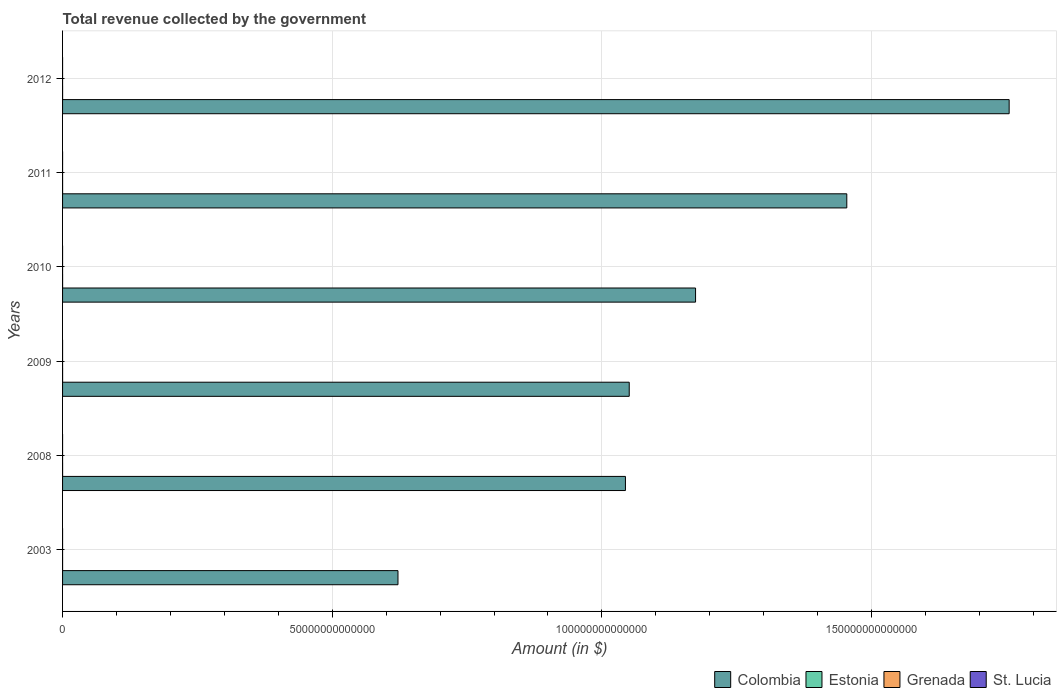How many bars are there on the 5th tick from the bottom?
Make the answer very short. 4. What is the label of the 2nd group of bars from the top?
Make the answer very short. 2011. What is the total revenue collected by the government in Estonia in 2012?
Your answer should be compact. 5.80e+09. Across all years, what is the maximum total revenue collected by the government in St. Lucia?
Provide a short and direct response. 8.17e+08. Across all years, what is the minimum total revenue collected by the government in St. Lucia?
Provide a succinct answer. 4.67e+08. In which year was the total revenue collected by the government in Estonia maximum?
Provide a succinct answer. 2012. What is the total total revenue collected by the government in Colombia in the graph?
Offer a very short reply. 7.10e+14. What is the difference between the total revenue collected by the government in Estonia in 2010 and that in 2011?
Give a very brief answer. -3.56e+08. What is the difference between the total revenue collected by the government in Grenada in 2011 and the total revenue collected by the government in Colombia in 2012?
Make the answer very short. -1.76e+14. What is the average total revenue collected by the government in Estonia per year?
Make the answer very short. 4.79e+09. In the year 2012, what is the difference between the total revenue collected by the government in Colombia and total revenue collected by the government in Estonia?
Provide a succinct answer. 1.76e+14. In how many years, is the total revenue collected by the government in Colombia greater than 30000000000000 $?
Provide a succinct answer. 6. What is the ratio of the total revenue collected by the government in Grenada in 2010 to that in 2012?
Offer a terse response. 0.98. Is the difference between the total revenue collected by the government in Colombia in 2009 and 2012 greater than the difference between the total revenue collected by the government in Estonia in 2009 and 2012?
Give a very brief answer. No. What is the difference between the highest and the second highest total revenue collected by the government in Colombia?
Provide a short and direct response. 3.01e+13. What is the difference between the highest and the lowest total revenue collected by the government in Colombia?
Make the answer very short. 1.13e+14. Is the sum of the total revenue collected by the government in Grenada in 2010 and 2011 greater than the maximum total revenue collected by the government in St. Lucia across all years?
Ensure brevity in your answer.  Yes. What does the 1st bar from the top in 2003 represents?
Provide a short and direct response. St. Lucia. What does the 3rd bar from the bottom in 2012 represents?
Give a very brief answer. Grenada. Are all the bars in the graph horizontal?
Provide a succinct answer. Yes. What is the difference between two consecutive major ticks on the X-axis?
Make the answer very short. 5.00e+13. Does the graph contain any zero values?
Provide a short and direct response. No. Does the graph contain grids?
Make the answer very short. Yes. Where does the legend appear in the graph?
Your answer should be compact. Bottom right. How many legend labels are there?
Provide a short and direct response. 4. How are the legend labels stacked?
Make the answer very short. Horizontal. What is the title of the graph?
Give a very brief answer. Total revenue collected by the government. What is the label or title of the X-axis?
Make the answer very short. Amount (in $). What is the Amount (in $) of Colombia in 2003?
Give a very brief answer. 6.22e+13. What is the Amount (in $) in Estonia in 2003?
Keep it short and to the point. 2.60e+09. What is the Amount (in $) in Grenada in 2003?
Offer a very short reply. 3.24e+08. What is the Amount (in $) in St. Lucia in 2003?
Offer a very short reply. 4.67e+08. What is the Amount (in $) of Colombia in 2008?
Offer a very short reply. 1.04e+14. What is the Amount (in $) in Estonia in 2008?
Ensure brevity in your answer.  4.98e+09. What is the Amount (in $) of Grenada in 2008?
Your answer should be very brief. 4.65e+08. What is the Amount (in $) in St. Lucia in 2008?
Offer a very short reply. 7.81e+08. What is the Amount (in $) of Colombia in 2009?
Keep it short and to the point. 1.05e+14. What is the Amount (in $) in Estonia in 2009?
Your answer should be very brief. 5.06e+09. What is the Amount (in $) in Grenada in 2009?
Provide a succinct answer. 4.02e+08. What is the Amount (in $) in St. Lucia in 2009?
Your answer should be compact. 7.71e+08. What is the Amount (in $) of Colombia in 2010?
Ensure brevity in your answer.  1.17e+14. What is the Amount (in $) in Estonia in 2010?
Provide a succinct answer. 4.96e+09. What is the Amount (in $) in Grenada in 2010?
Make the answer very short. 4.15e+08. What is the Amount (in $) of St. Lucia in 2010?
Offer a very short reply. 7.76e+08. What is the Amount (in $) of Colombia in 2011?
Offer a terse response. 1.45e+14. What is the Amount (in $) in Estonia in 2011?
Offer a very short reply. 5.31e+09. What is the Amount (in $) of Grenada in 2011?
Your answer should be very brief. 4.26e+08. What is the Amount (in $) in St. Lucia in 2011?
Keep it short and to the point. 8.17e+08. What is the Amount (in $) of Colombia in 2012?
Offer a very short reply. 1.76e+14. What is the Amount (in $) in Estonia in 2012?
Give a very brief answer. 5.80e+09. What is the Amount (in $) in Grenada in 2012?
Make the answer very short. 4.25e+08. What is the Amount (in $) in St. Lucia in 2012?
Provide a succinct answer. 8.10e+08. Across all years, what is the maximum Amount (in $) of Colombia?
Offer a terse response. 1.76e+14. Across all years, what is the maximum Amount (in $) of Estonia?
Offer a terse response. 5.80e+09. Across all years, what is the maximum Amount (in $) of Grenada?
Your answer should be compact. 4.65e+08. Across all years, what is the maximum Amount (in $) of St. Lucia?
Make the answer very short. 8.17e+08. Across all years, what is the minimum Amount (in $) in Colombia?
Give a very brief answer. 6.22e+13. Across all years, what is the minimum Amount (in $) in Estonia?
Offer a terse response. 2.60e+09. Across all years, what is the minimum Amount (in $) in Grenada?
Keep it short and to the point. 3.24e+08. Across all years, what is the minimum Amount (in $) in St. Lucia?
Provide a succinct answer. 4.67e+08. What is the total Amount (in $) of Colombia in the graph?
Your response must be concise. 7.10e+14. What is the total Amount (in $) in Estonia in the graph?
Keep it short and to the point. 2.87e+1. What is the total Amount (in $) of Grenada in the graph?
Your answer should be compact. 2.46e+09. What is the total Amount (in $) of St. Lucia in the graph?
Your answer should be very brief. 4.42e+09. What is the difference between the Amount (in $) of Colombia in 2003 and that in 2008?
Offer a terse response. -4.22e+13. What is the difference between the Amount (in $) of Estonia in 2003 and that in 2008?
Your answer should be compact. -2.39e+09. What is the difference between the Amount (in $) of Grenada in 2003 and that in 2008?
Provide a succinct answer. -1.41e+08. What is the difference between the Amount (in $) in St. Lucia in 2003 and that in 2008?
Your answer should be compact. -3.15e+08. What is the difference between the Amount (in $) in Colombia in 2003 and that in 2009?
Your answer should be compact. -4.29e+13. What is the difference between the Amount (in $) of Estonia in 2003 and that in 2009?
Your response must be concise. -2.47e+09. What is the difference between the Amount (in $) of Grenada in 2003 and that in 2009?
Your answer should be compact. -7.82e+07. What is the difference between the Amount (in $) in St. Lucia in 2003 and that in 2009?
Provide a short and direct response. -3.04e+08. What is the difference between the Amount (in $) of Colombia in 2003 and that in 2010?
Your answer should be very brief. -5.52e+13. What is the difference between the Amount (in $) in Estonia in 2003 and that in 2010?
Provide a succinct answer. -2.36e+09. What is the difference between the Amount (in $) in Grenada in 2003 and that in 2010?
Offer a very short reply. -9.14e+07. What is the difference between the Amount (in $) of St. Lucia in 2003 and that in 2010?
Your response must be concise. -3.10e+08. What is the difference between the Amount (in $) of Colombia in 2003 and that in 2011?
Provide a succinct answer. -8.32e+13. What is the difference between the Amount (in $) of Estonia in 2003 and that in 2011?
Make the answer very short. -2.72e+09. What is the difference between the Amount (in $) of Grenada in 2003 and that in 2011?
Offer a very short reply. -1.02e+08. What is the difference between the Amount (in $) in St. Lucia in 2003 and that in 2011?
Make the answer very short. -3.50e+08. What is the difference between the Amount (in $) of Colombia in 2003 and that in 2012?
Give a very brief answer. -1.13e+14. What is the difference between the Amount (in $) in Estonia in 2003 and that in 2012?
Offer a very short reply. -3.20e+09. What is the difference between the Amount (in $) of Grenada in 2003 and that in 2012?
Offer a terse response. -1.02e+08. What is the difference between the Amount (in $) in St. Lucia in 2003 and that in 2012?
Your response must be concise. -3.44e+08. What is the difference between the Amount (in $) of Colombia in 2008 and that in 2009?
Offer a very short reply. -7.04e+11. What is the difference between the Amount (in $) in Estonia in 2008 and that in 2009?
Offer a very short reply. -7.78e+07. What is the difference between the Amount (in $) in Grenada in 2008 and that in 2009?
Offer a terse response. 6.28e+07. What is the difference between the Amount (in $) in St. Lucia in 2008 and that in 2009?
Provide a succinct answer. 1.03e+07. What is the difference between the Amount (in $) of Colombia in 2008 and that in 2010?
Ensure brevity in your answer.  -1.30e+13. What is the difference between the Amount (in $) in Estonia in 2008 and that in 2010?
Provide a short and direct response. 2.82e+07. What is the difference between the Amount (in $) of Grenada in 2008 and that in 2010?
Your response must be concise. 4.96e+07. What is the difference between the Amount (in $) in St. Lucia in 2008 and that in 2010?
Ensure brevity in your answer.  4.90e+06. What is the difference between the Amount (in $) of Colombia in 2008 and that in 2011?
Keep it short and to the point. -4.10e+13. What is the difference between the Amount (in $) in Estonia in 2008 and that in 2011?
Give a very brief answer. -3.28e+08. What is the difference between the Amount (in $) in Grenada in 2008 and that in 2011?
Provide a short and direct response. 3.89e+07. What is the difference between the Amount (in $) of St. Lucia in 2008 and that in 2011?
Your answer should be very brief. -3.54e+07. What is the difference between the Amount (in $) of Colombia in 2008 and that in 2012?
Your answer should be very brief. -7.12e+13. What is the difference between the Amount (in $) of Estonia in 2008 and that in 2012?
Your response must be concise. -8.14e+08. What is the difference between the Amount (in $) in Grenada in 2008 and that in 2012?
Keep it short and to the point. 3.93e+07. What is the difference between the Amount (in $) of St. Lucia in 2008 and that in 2012?
Provide a succinct answer. -2.92e+07. What is the difference between the Amount (in $) in Colombia in 2009 and that in 2010?
Ensure brevity in your answer.  -1.23e+13. What is the difference between the Amount (in $) of Estonia in 2009 and that in 2010?
Your answer should be compact. 1.06e+08. What is the difference between the Amount (in $) in Grenada in 2009 and that in 2010?
Provide a succinct answer. -1.32e+07. What is the difference between the Amount (in $) in St. Lucia in 2009 and that in 2010?
Your answer should be very brief. -5.40e+06. What is the difference between the Amount (in $) of Colombia in 2009 and that in 2011?
Make the answer very short. -4.03e+13. What is the difference between the Amount (in $) of Estonia in 2009 and that in 2011?
Ensure brevity in your answer.  -2.50e+08. What is the difference between the Amount (in $) of Grenada in 2009 and that in 2011?
Offer a very short reply. -2.39e+07. What is the difference between the Amount (in $) in St. Lucia in 2009 and that in 2011?
Give a very brief answer. -4.57e+07. What is the difference between the Amount (in $) in Colombia in 2009 and that in 2012?
Ensure brevity in your answer.  -7.05e+13. What is the difference between the Amount (in $) in Estonia in 2009 and that in 2012?
Keep it short and to the point. -7.36e+08. What is the difference between the Amount (in $) of Grenada in 2009 and that in 2012?
Your answer should be compact. -2.35e+07. What is the difference between the Amount (in $) of St. Lucia in 2009 and that in 2012?
Keep it short and to the point. -3.95e+07. What is the difference between the Amount (in $) of Colombia in 2010 and that in 2011?
Provide a short and direct response. -2.80e+13. What is the difference between the Amount (in $) in Estonia in 2010 and that in 2011?
Ensure brevity in your answer.  -3.56e+08. What is the difference between the Amount (in $) of Grenada in 2010 and that in 2011?
Your answer should be compact. -1.07e+07. What is the difference between the Amount (in $) of St. Lucia in 2010 and that in 2011?
Offer a very short reply. -4.03e+07. What is the difference between the Amount (in $) of Colombia in 2010 and that in 2012?
Your answer should be compact. -5.81e+13. What is the difference between the Amount (in $) of Estonia in 2010 and that in 2012?
Your answer should be very brief. -8.42e+08. What is the difference between the Amount (in $) of Grenada in 2010 and that in 2012?
Provide a succinct answer. -1.03e+07. What is the difference between the Amount (in $) of St. Lucia in 2010 and that in 2012?
Your answer should be very brief. -3.41e+07. What is the difference between the Amount (in $) in Colombia in 2011 and that in 2012?
Ensure brevity in your answer.  -3.01e+13. What is the difference between the Amount (in $) in Estonia in 2011 and that in 2012?
Your response must be concise. -4.86e+08. What is the difference between the Amount (in $) in St. Lucia in 2011 and that in 2012?
Offer a terse response. 6.20e+06. What is the difference between the Amount (in $) of Colombia in 2003 and the Amount (in $) of Estonia in 2008?
Give a very brief answer. 6.22e+13. What is the difference between the Amount (in $) of Colombia in 2003 and the Amount (in $) of Grenada in 2008?
Make the answer very short. 6.22e+13. What is the difference between the Amount (in $) of Colombia in 2003 and the Amount (in $) of St. Lucia in 2008?
Your response must be concise. 6.22e+13. What is the difference between the Amount (in $) in Estonia in 2003 and the Amount (in $) in Grenada in 2008?
Give a very brief answer. 2.13e+09. What is the difference between the Amount (in $) in Estonia in 2003 and the Amount (in $) in St. Lucia in 2008?
Give a very brief answer. 1.82e+09. What is the difference between the Amount (in $) in Grenada in 2003 and the Amount (in $) in St. Lucia in 2008?
Your answer should be very brief. -4.58e+08. What is the difference between the Amount (in $) of Colombia in 2003 and the Amount (in $) of Estonia in 2009?
Your answer should be very brief. 6.22e+13. What is the difference between the Amount (in $) of Colombia in 2003 and the Amount (in $) of Grenada in 2009?
Offer a very short reply. 6.22e+13. What is the difference between the Amount (in $) of Colombia in 2003 and the Amount (in $) of St. Lucia in 2009?
Provide a short and direct response. 6.22e+13. What is the difference between the Amount (in $) in Estonia in 2003 and the Amount (in $) in Grenada in 2009?
Your response must be concise. 2.20e+09. What is the difference between the Amount (in $) in Estonia in 2003 and the Amount (in $) in St. Lucia in 2009?
Make the answer very short. 1.83e+09. What is the difference between the Amount (in $) in Grenada in 2003 and the Amount (in $) in St. Lucia in 2009?
Make the answer very short. -4.47e+08. What is the difference between the Amount (in $) of Colombia in 2003 and the Amount (in $) of Estonia in 2010?
Provide a succinct answer. 6.22e+13. What is the difference between the Amount (in $) in Colombia in 2003 and the Amount (in $) in Grenada in 2010?
Your answer should be very brief. 6.22e+13. What is the difference between the Amount (in $) of Colombia in 2003 and the Amount (in $) of St. Lucia in 2010?
Make the answer very short. 6.22e+13. What is the difference between the Amount (in $) in Estonia in 2003 and the Amount (in $) in Grenada in 2010?
Provide a succinct answer. 2.18e+09. What is the difference between the Amount (in $) in Estonia in 2003 and the Amount (in $) in St. Lucia in 2010?
Your response must be concise. 1.82e+09. What is the difference between the Amount (in $) in Grenada in 2003 and the Amount (in $) in St. Lucia in 2010?
Offer a terse response. -4.53e+08. What is the difference between the Amount (in $) in Colombia in 2003 and the Amount (in $) in Estonia in 2011?
Make the answer very short. 6.22e+13. What is the difference between the Amount (in $) of Colombia in 2003 and the Amount (in $) of Grenada in 2011?
Provide a short and direct response. 6.22e+13. What is the difference between the Amount (in $) in Colombia in 2003 and the Amount (in $) in St. Lucia in 2011?
Provide a succinct answer. 6.22e+13. What is the difference between the Amount (in $) in Estonia in 2003 and the Amount (in $) in Grenada in 2011?
Ensure brevity in your answer.  2.17e+09. What is the difference between the Amount (in $) of Estonia in 2003 and the Amount (in $) of St. Lucia in 2011?
Make the answer very short. 1.78e+09. What is the difference between the Amount (in $) of Grenada in 2003 and the Amount (in $) of St. Lucia in 2011?
Your answer should be very brief. -4.93e+08. What is the difference between the Amount (in $) in Colombia in 2003 and the Amount (in $) in Estonia in 2012?
Your answer should be compact. 6.22e+13. What is the difference between the Amount (in $) of Colombia in 2003 and the Amount (in $) of Grenada in 2012?
Make the answer very short. 6.22e+13. What is the difference between the Amount (in $) in Colombia in 2003 and the Amount (in $) in St. Lucia in 2012?
Make the answer very short. 6.22e+13. What is the difference between the Amount (in $) in Estonia in 2003 and the Amount (in $) in Grenada in 2012?
Provide a succinct answer. 2.17e+09. What is the difference between the Amount (in $) in Estonia in 2003 and the Amount (in $) in St. Lucia in 2012?
Your answer should be very brief. 1.79e+09. What is the difference between the Amount (in $) in Grenada in 2003 and the Amount (in $) in St. Lucia in 2012?
Make the answer very short. -4.87e+08. What is the difference between the Amount (in $) of Colombia in 2008 and the Amount (in $) of Estonia in 2009?
Provide a succinct answer. 1.04e+14. What is the difference between the Amount (in $) in Colombia in 2008 and the Amount (in $) in Grenada in 2009?
Ensure brevity in your answer.  1.04e+14. What is the difference between the Amount (in $) in Colombia in 2008 and the Amount (in $) in St. Lucia in 2009?
Your answer should be compact. 1.04e+14. What is the difference between the Amount (in $) in Estonia in 2008 and the Amount (in $) in Grenada in 2009?
Keep it short and to the point. 4.58e+09. What is the difference between the Amount (in $) of Estonia in 2008 and the Amount (in $) of St. Lucia in 2009?
Offer a very short reply. 4.21e+09. What is the difference between the Amount (in $) of Grenada in 2008 and the Amount (in $) of St. Lucia in 2009?
Offer a very short reply. -3.06e+08. What is the difference between the Amount (in $) of Colombia in 2008 and the Amount (in $) of Estonia in 2010?
Your answer should be compact. 1.04e+14. What is the difference between the Amount (in $) of Colombia in 2008 and the Amount (in $) of Grenada in 2010?
Keep it short and to the point. 1.04e+14. What is the difference between the Amount (in $) in Colombia in 2008 and the Amount (in $) in St. Lucia in 2010?
Your response must be concise. 1.04e+14. What is the difference between the Amount (in $) in Estonia in 2008 and the Amount (in $) in Grenada in 2010?
Provide a succinct answer. 4.57e+09. What is the difference between the Amount (in $) in Estonia in 2008 and the Amount (in $) in St. Lucia in 2010?
Ensure brevity in your answer.  4.21e+09. What is the difference between the Amount (in $) in Grenada in 2008 and the Amount (in $) in St. Lucia in 2010?
Your answer should be compact. -3.12e+08. What is the difference between the Amount (in $) in Colombia in 2008 and the Amount (in $) in Estonia in 2011?
Keep it short and to the point. 1.04e+14. What is the difference between the Amount (in $) in Colombia in 2008 and the Amount (in $) in Grenada in 2011?
Offer a very short reply. 1.04e+14. What is the difference between the Amount (in $) of Colombia in 2008 and the Amount (in $) of St. Lucia in 2011?
Ensure brevity in your answer.  1.04e+14. What is the difference between the Amount (in $) in Estonia in 2008 and the Amount (in $) in Grenada in 2011?
Offer a terse response. 4.56e+09. What is the difference between the Amount (in $) of Estonia in 2008 and the Amount (in $) of St. Lucia in 2011?
Your answer should be compact. 4.17e+09. What is the difference between the Amount (in $) in Grenada in 2008 and the Amount (in $) in St. Lucia in 2011?
Your answer should be very brief. -3.52e+08. What is the difference between the Amount (in $) in Colombia in 2008 and the Amount (in $) in Estonia in 2012?
Your response must be concise. 1.04e+14. What is the difference between the Amount (in $) of Colombia in 2008 and the Amount (in $) of Grenada in 2012?
Your answer should be very brief. 1.04e+14. What is the difference between the Amount (in $) of Colombia in 2008 and the Amount (in $) of St. Lucia in 2012?
Offer a terse response. 1.04e+14. What is the difference between the Amount (in $) in Estonia in 2008 and the Amount (in $) in Grenada in 2012?
Provide a short and direct response. 4.56e+09. What is the difference between the Amount (in $) in Estonia in 2008 and the Amount (in $) in St. Lucia in 2012?
Make the answer very short. 4.17e+09. What is the difference between the Amount (in $) in Grenada in 2008 and the Amount (in $) in St. Lucia in 2012?
Your answer should be very brief. -3.46e+08. What is the difference between the Amount (in $) of Colombia in 2009 and the Amount (in $) of Estonia in 2010?
Make the answer very short. 1.05e+14. What is the difference between the Amount (in $) of Colombia in 2009 and the Amount (in $) of Grenada in 2010?
Make the answer very short. 1.05e+14. What is the difference between the Amount (in $) of Colombia in 2009 and the Amount (in $) of St. Lucia in 2010?
Offer a terse response. 1.05e+14. What is the difference between the Amount (in $) of Estonia in 2009 and the Amount (in $) of Grenada in 2010?
Provide a short and direct response. 4.65e+09. What is the difference between the Amount (in $) of Estonia in 2009 and the Amount (in $) of St. Lucia in 2010?
Provide a short and direct response. 4.29e+09. What is the difference between the Amount (in $) of Grenada in 2009 and the Amount (in $) of St. Lucia in 2010?
Your response must be concise. -3.74e+08. What is the difference between the Amount (in $) in Colombia in 2009 and the Amount (in $) in Estonia in 2011?
Keep it short and to the point. 1.05e+14. What is the difference between the Amount (in $) of Colombia in 2009 and the Amount (in $) of Grenada in 2011?
Make the answer very short. 1.05e+14. What is the difference between the Amount (in $) of Colombia in 2009 and the Amount (in $) of St. Lucia in 2011?
Your answer should be compact. 1.05e+14. What is the difference between the Amount (in $) of Estonia in 2009 and the Amount (in $) of Grenada in 2011?
Offer a terse response. 4.64e+09. What is the difference between the Amount (in $) in Estonia in 2009 and the Amount (in $) in St. Lucia in 2011?
Offer a very short reply. 4.25e+09. What is the difference between the Amount (in $) of Grenada in 2009 and the Amount (in $) of St. Lucia in 2011?
Provide a short and direct response. -4.15e+08. What is the difference between the Amount (in $) in Colombia in 2009 and the Amount (in $) in Estonia in 2012?
Give a very brief answer. 1.05e+14. What is the difference between the Amount (in $) of Colombia in 2009 and the Amount (in $) of Grenada in 2012?
Provide a short and direct response. 1.05e+14. What is the difference between the Amount (in $) in Colombia in 2009 and the Amount (in $) in St. Lucia in 2012?
Keep it short and to the point. 1.05e+14. What is the difference between the Amount (in $) of Estonia in 2009 and the Amount (in $) of Grenada in 2012?
Provide a succinct answer. 4.64e+09. What is the difference between the Amount (in $) in Estonia in 2009 and the Amount (in $) in St. Lucia in 2012?
Your answer should be compact. 4.25e+09. What is the difference between the Amount (in $) in Grenada in 2009 and the Amount (in $) in St. Lucia in 2012?
Make the answer very short. -4.09e+08. What is the difference between the Amount (in $) in Colombia in 2010 and the Amount (in $) in Estonia in 2011?
Provide a short and direct response. 1.17e+14. What is the difference between the Amount (in $) in Colombia in 2010 and the Amount (in $) in Grenada in 2011?
Your response must be concise. 1.17e+14. What is the difference between the Amount (in $) in Colombia in 2010 and the Amount (in $) in St. Lucia in 2011?
Give a very brief answer. 1.17e+14. What is the difference between the Amount (in $) of Estonia in 2010 and the Amount (in $) of Grenada in 2011?
Your answer should be compact. 4.53e+09. What is the difference between the Amount (in $) of Estonia in 2010 and the Amount (in $) of St. Lucia in 2011?
Your answer should be very brief. 4.14e+09. What is the difference between the Amount (in $) in Grenada in 2010 and the Amount (in $) in St. Lucia in 2011?
Ensure brevity in your answer.  -4.02e+08. What is the difference between the Amount (in $) of Colombia in 2010 and the Amount (in $) of Estonia in 2012?
Make the answer very short. 1.17e+14. What is the difference between the Amount (in $) in Colombia in 2010 and the Amount (in $) in Grenada in 2012?
Offer a terse response. 1.17e+14. What is the difference between the Amount (in $) of Colombia in 2010 and the Amount (in $) of St. Lucia in 2012?
Your answer should be compact. 1.17e+14. What is the difference between the Amount (in $) in Estonia in 2010 and the Amount (in $) in Grenada in 2012?
Offer a very short reply. 4.53e+09. What is the difference between the Amount (in $) in Estonia in 2010 and the Amount (in $) in St. Lucia in 2012?
Offer a terse response. 4.15e+09. What is the difference between the Amount (in $) of Grenada in 2010 and the Amount (in $) of St. Lucia in 2012?
Provide a succinct answer. -3.95e+08. What is the difference between the Amount (in $) of Colombia in 2011 and the Amount (in $) of Estonia in 2012?
Offer a terse response. 1.45e+14. What is the difference between the Amount (in $) in Colombia in 2011 and the Amount (in $) in Grenada in 2012?
Give a very brief answer. 1.45e+14. What is the difference between the Amount (in $) of Colombia in 2011 and the Amount (in $) of St. Lucia in 2012?
Your answer should be very brief. 1.45e+14. What is the difference between the Amount (in $) in Estonia in 2011 and the Amount (in $) in Grenada in 2012?
Your answer should be very brief. 4.89e+09. What is the difference between the Amount (in $) of Estonia in 2011 and the Amount (in $) of St. Lucia in 2012?
Your response must be concise. 4.50e+09. What is the difference between the Amount (in $) in Grenada in 2011 and the Amount (in $) in St. Lucia in 2012?
Offer a very short reply. -3.85e+08. What is the average Amount (in $) of Colombia per year?
Keep it short and to the point. 1.18e+14. What is the average Amount (in $) of Estonia per year?
Offer a terse response. 4.79e+09. What is the average Amount (in $) in Grenada per year?
Offer a terse response. 4.09e+08. What is the average Amount (in $) of St. Lucia per year?
Offer a very short reply. 7.37e+08. In the year 2003, what is the difference between the Amount (in $) of Colombia and Amount (in $) of Estonia?
Ensure brevity in your answer.  6.22e+13. In the year 2003, what is the difference between the Amount (in $) of Colombia and Amount (in $) of Grenada?
Make the answer very short. 6.22e+13. In the year 2003, what is the difference between the Amount (in $) of Colombia and Amount (in $) of St. Lucia?
Provide a short and direct response. 6.22e+13. In the year 2003, what is the difference between the Amount (in $) of Estonia and Amount (in $) of Grenada?
Give a very brief answer. 2.27e+09. In the year 2003, what is the difference between the Amount (in $) of Estonia and Amount (in $) of St. Lucia?
Provide a short and direct response. 2.13e+09. In the year 2003, what is the difference between the Amount (in $) in Grenada and Amount (in $) in St. Lucia?
Make the answer very short. -1.43e+08. In the year 2008, what is the difference between the Amount (in $) in Colombia and Amount (in $) in Estonia?
Offer a terse response. 1.04e+14. In the year 2008, what is the difference between the Amount (in $) of Colombia and Amount (in $) of Grenada?
Keep it short and to the point. 1.04e+14. In the year 2008, what is the difference between the Amount (in $) in Colombia and Amount (in $) in St. Lucia?
Ensure brevity in your answer.  1.04e+14. In the year 2008, what is the difference between the Amount (in $) of Estonia and Amount (in $) of Grenada?
Your answer should be compact. 4.52e+09. In the year 2008, what is the difference between the Amount (in $) of Estonia and Amount (in $) of St. Lucia?
Your answer should be compact. 4.20e+09. In the year 2008, what is the difference between the Amount (in $) in Grenada and Amount (in $) in St. Lucia?
Your answer should be compact. -3.17e+08. In the year 2009, what is the difference between the Amount (in $) in Colombia and Amount (in $) in Estonia?
Keep it short and to the point. 1.05e+14. In the year 2009, what is the difference between the Amount (in $) of Colombia and Amount (in $) of Grenada?
Give a very brief answer. 1.05e+14. In the year 2009, what is the difference between the Amount (in $) in Colombia and Amount (in $) in St. Lucia?
Offer a terse response. 1.05e+14. In the year 2009, what is the difference between the Amount (in $) of Estonia and Amount (in $) of Grenada?
Ensure brevity in your answer.  4.66e+09. In the year 2009, what is the difference between the Amount (in $) of Estonia and Amount (in $) of St. Lucia?
Provide a succinct answer. 4.29e+09. In the year 2009, what is the difference between the Amount (in $) in Grenada and Amount (in $) in St. Lucia?
Offer a terse response. -3.69e+08. In the year 2010, what is the difference between the Amount (in $) in Colombia and Amount (in $) in Estonia?
Offer a very short reply. 1.17e+14. In the year 2010, what is the difference between the Amount (in $) in Colombia and Amount (in $) in Grenada?
Give a very brief answer. 1.17e+14. In the year 2010, what is the difference between the Amount (in $) in Colombia and Amount (in $) in St. Lucia?
Make the answer very short. 1.17e+14. In the year 2010, what is the difference between the Amount (in $) of Estonia and Amount (in $) of Grenada?
Offer a very short reply. 4.54e+09. In the year 2010, what is the difference between the Amount (in $) in Estonia and Amount (in $) in St. Lucia?
Your answer should be compact. 4.18e+09. In the year 2010, what is the difference between the Amount (in $) of Grenada and Amount (in $) of St. Lucia?
Provide a short and direct response. -3.61e+08. In the year 2011, what is the difference between the Amount (in $) of Colombia and Amount (in $) of Estonia?
Offer a very short reply. 1.45e+14. In the year 2011, what is the difference between the Amount (in $) in Colombia and Amount (in $) in Grenada?
Provide a short and direct response. 1.45e+14. In the year 2011, what is the difference between the Amount (in $) in Colombia and Amount (in $) in St. Lucia?
Give a very brief answer. 1.45e+14. In the year 2011, what is the difference between the Amount (in $) of Estonia and Amount (in $) of Grenada?
Your answer should be very brief. 4.89e+09. In the year 2011, what is the difference between the Amount (in $) of Estonia and Amount (in $) of St. Lucia?
Your answer should be very brief. 4.50e+09. In the year 2011, what is the difference between the Amount (in $) of Grenada and Amount (in $) of St. Lucia?
Offer a terse response. -3.91e+08. In the year 2012, what is the difference between the Amount (in $) of Colombia and Amount (in $) of Estonia?
Ensure brevity in your answer.  1.76e+14. In the year 2012, what is the difference between the Amount (in $) of Colombia and Amount (in $) of Grenada?
Your response must be concise. 1.76e+14. In the year 2012, what is the difference between the Amount (in $) in Colombia and Amount (in $) in St. Lucia?
Provide a succinct answer. 1.76e+14. In the year 2012, what is the difference between the Amount (in $) of Estonia and Amount (in $) of Grenada?
Ensure brevity in your answer.  5.37e+09. In the year 2012, what is the difference between the Amount (in $) in Estonia and Amount (in $) in St. Lucia?
Your answer should be very brief. 4.99e+09. In the year 2012, what is the difference between the Amount (in $) of Grenada and Amount (in $) of St. Lucia?
Ensure brevity in your answer.  -3.85e+08. What is the ratio of the Amount (in $) in Colombia in 2003 to that in 2008?
Your answer should be very brief. 0.6. What is the ratio of the Amount (in $) of Estonia in 2003 to that in 2008?
Ensure brevity in your answer.  0.52. What is the ratio of the Amount (in $) of Grenada in 2003 to that in 2008?
Offer a very short reply. 0.7. What is the ratio of the Amount (in $) of St. Lucia in 2003 to that in 2008?
Provide a short and direct response. 0.6. What is the ratio of the Amount (in $) in Colombia in 2003 to that in 2009?
Keep it short and to the point. 0.59. What is the ratio of the Amount (in $) of Estonia in 2003 to that in 2009?
Keep it short and to the point. 0.51. What is the ratio of the Amount (in $) in Grenada in 2003 to that in 2009?
Your answer should be compact. 0.81. What is the ratio of the Amount (in $) in St. Lucia in 2003 to that in 2009?
Keep it short and to the point. 0.61. What is the ratio of the Amount (in $) in Colombia in 2003 to that in 2010?
Provide a succinct answer. 0.53. What is the ratio of the Amount (in $) of Estonia in 2003 to that in 2010?
Ensure brevity in your answer.  0.52. What is the ratio of the Amount (in $) of Grenada in 2003 to that in 2010?
Keep it short and to the point. 0.78. What is the ratio of the Amount (in $) of St. Lucia in 2003 to that in 2010?
Your answer should be compact. 0.6. What is the ratio of the Amount (in $) in Colombia in 2003 to that in 2011?
Your answer should be compact. 0.43. What is the ratio of the Amount (in $) of Estonia in 2003 to that in 2011?
Keep it short and to the point. 0.49. What is the ratio of the Amount (in $) in Grenada in 2003 to that in 2011?
Ensure brevity in your answer.  0.76. What is the ratio of the Amount (in $) in Colombia in 2003 to that in 2012?
Your response must be concise. 0.35. What is the ratio of the Amount (in $) in Estonia in 2003 to that in 2012?
Provide a succinct answer. 0.45. What is the ratio of the Amount (in $) in Grenada in 2003 to that in 2012?
Give a very brief answer. 0.76. What is the ratio of the Amount (in $) of St. Lucia in 2003 to that in 2012?
Give a very brief answer. 0.58. What is the ratio of the Amount (in $) of Colombia in 2008 to that in 2009?
Offer a very short reply. 0.99. What is the ratio of the Amount (in $) in Estonia in 2008 to that in 2009?
Make the answer very short. 0.98. What is the ratio of the Amount (in $) in Grenada in 2008 to that in 2009?
Make the answer very short. 1.16. What is the ratio of the Amount (in $) of St. Lucia in 2008 to that in 2009?
Make the answer very short. 1.01. What is the ratio of the Amount (in $) of Colombia in 2008 to that in 2010?
Your answer should be very brief. 0.89. What is the ratio of the Amount (in $) in Grenada in 2008 to that in 2010?
Ensure brevity in your answer.  1.12. What is the ratio of the Amount (in $) of St. Lucia in 2008 to that in 2010?
Provide a short and direct response. 1.01. What is the ratio of the Amount (in $) of Colombia in 2008 to that in 2011?
Keep it short and to the point. 0.72. What is the ratio of the Amount (in $) in Estonia in 2008 to that in 2011?
Your response must be concise. 0.94. What is the ratio of the Amount (in $) of Grenada in 2008 to that in 2011?
Provide a succinct answer. 1.09. What is the ratio of the Amount (in $) in St. Lucia in 2008 to that in 2011?
Offer a terse response. 0.96. What is the ratio of the Amount (in $) in Colombia in 2008 to that in 2012?
Your response must be concise. 0.59. What is the ratio of the Amount (in $) in Estonia in 2008 to that in 2012?
Provide a short and direct response. 0.86. What is the ratio of the Amount (in $) in Grenada in 2008 to that in 2012?
Your answer should be compact. 1.09. What is the ratio of the Amount (in $) in St. Lucia in 2008 to that in 2012?
Give a very brief answer. 0.96. What is the ratio of the Amount (in $) of Colombia in 2009 to that in 2010?
Your answer should be very brief. 0.9. What is the ratio of the Amount (in $) of Estonia in 2009 to that in 2010?
Your answer should be compact. 1.02. What is the ratio of the Amount (in $) of Grenada in 2009 to that in 2010?
Offer a very short reply. 0.97. What is the ratio of the Amount (in $) of St. Lucia in 2009 to that in 2010?
Provide a short and direct response. 0.99. What is the ratio of the Amount (in $) of Colombia in 2009 to that in 2011?
Make the answer very short. 0.72. What is the ratio of the Amount (in $) in Estonia in 2009 to that in 2011?
Make the answer very short. 0.95. What is the ratio of the Amount (in $) of Grenada in 2009 to that in 2011?
Your answer should be compact. 0.94. What is the ratio of the Amount (in $) of St. Lucia in 2009 to that in 2011?
Your answer should be compact. 0.94. What is the ratio of the Amount (in $) of Colombia in 2009 to that in 2012?
Provide a succinct answer. 0.6. What is the ratio of the Amount (in $) of Estonia in 2009 to that in 2012?
Offer a terse response. 0.87. What is the ratio of the Amount (in $) in Grenada in 2009 to that in 2012?
Offer a very short reply. 0.94. What is the ratio of the Amount (in $) of St. Lucia in 2009 to that in 2012?
Provide a short and direct response. 0.95. What is the ratio of the Amount (in $) in Colombia in 2010 to that in 2011?
Make the answer very short. 0.81. What is the ratio of the Amount (in $) of Estonia in 2010 to that in 2011?
Your answer should be very brief. 0.93. What is the ratio of the Amount (in $) in Grenada in 2010 to that in 2011?
Offer a very short reply. 0.97. What is the ratio of the Amount (in $) of St. Lucia in 2010 to that in 2011?
Keep it short and to the point. 0.95. What is the ratio of the Amount (in $) in Colombia in 2010 to that in 2012?
Provide a succinct answer. 0.67. What is the ratio of the Amount (in $) of Estonia in 2010 to that in 2012?
Keep it short and to the point. 0.85. What is the ratio of the Amount (in $) of Grenada in 2010 to that in 2012?
Provide a short and direct response. 0.98. What is the ratio of the Amount (in $) in St. Lucia in 2010 to that in 2012?
Your response must be concise. 0.96. What is the ratio of the Amount (in $) in Colombia in 2011 to that in 2012?
Give a very brief answer. 0.83. What is the ratio of the Amount (in $) of Estonia in 2011 to that in 2012?
Your answer should be very brief. 0.92. What is the ratio of the Amount (in $) of St. Lucia in 2011 to that in 2012?
Provide a short and direct response. 1.01. What is the difference between the highest and the second highest Amount (in $) of Colombia?
Offer a very short reply. 3.01e+13. What is the difference between the highest and the second highest Amount (in $) of Estonia?
Keep it short and to the point. 4.86e+08. What is the difference between the highest and the second highest Amount (in $) in Grenada?
Your answer should be very brief. 3.89e+07. What is the difference between the highest and the second highest Amount (in $) in St. Lucia?
Give a very brief answer. 6.20e+06. What is the difference between the highest and the lowest Amount (in $) of Colombia?
Keep it short and to the point. 1.13e+14. What is the difference between the highest and the lowest Amount (in $) in Estonia?
Keep it short and to the point. 3.20e+09. What is the difference between the highest and the lowest Amount (in $) of Grenada?
Provide a succinct answer. 1.41e+08. What is the difference between the highest and the lowest Amount (in $) in St. Lucia?
Your answer should be compact. 3.50e+08. 